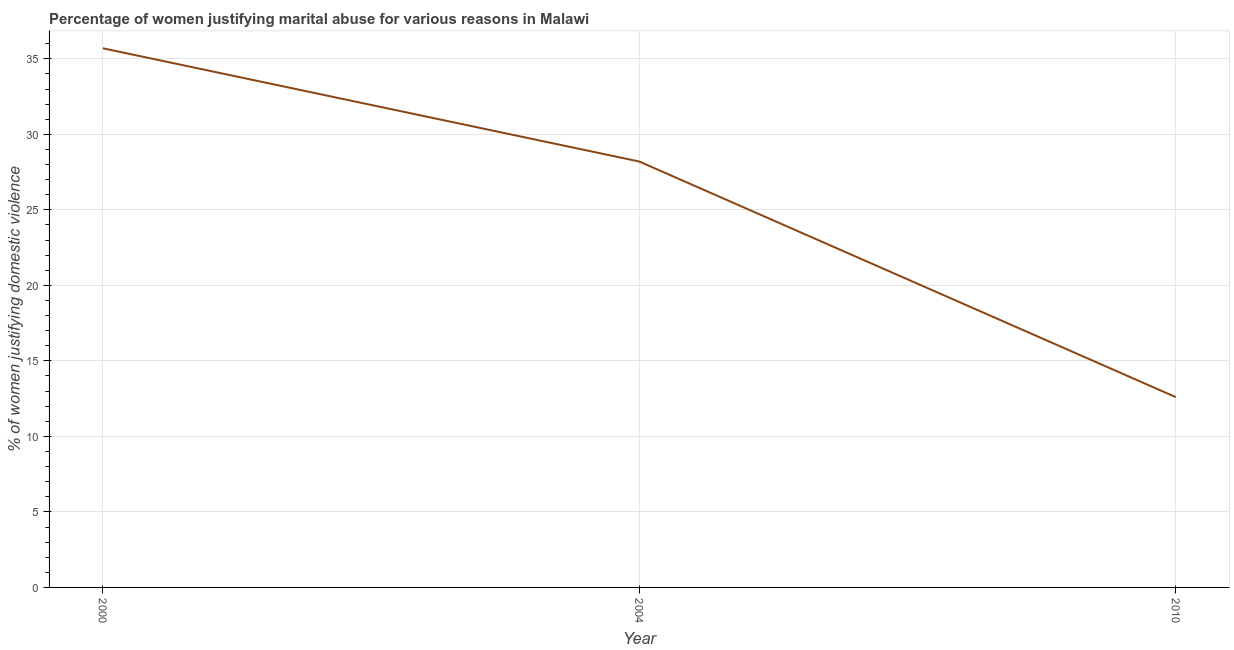What is the percentage of women justifying marital abuse in 2004?
Offer a terse response. 28.2. Across all years, what is the maximum percentage of women justifying marital abuse?
Provide a short and direct response. 35.7. Across all years, what is the minimum percentage of women justifying marital abuse?
Provide a short and direct response. 12.6. In which year was the percentage of women justifying marital abuse minimum?
Provide a short and direct response. 2010. What is the sum of the percentage of women justifying marital abuse?
Give a very brief answer. 76.5. What is the difference between the percentage of women justifying marital abuse in 2000 and 2010?
Give a very brief answer. 23.1. What is the average percentage of women justifying marital abuse per year?
Your response must be concise. 25.5. What is the median percentage of women justifying marital abuse?
Provide a short and direct response. 28.2. In how many years, is the percentage of women justifying marital abuse greater than 31 %?
Provide a short and direct response. 1. Do a majority of the years between 2010 and 2004 (inclusive) have percentage of women justifying marital abuse greater than 20 %?
Provide a short and direct response. No. What is the ratio of the percentage of women justifying marital abuse in 2000 to that in 2004?
Offer a very short reply. 1.27. Is the percentage of women justifying marital abuse in 2000 less than that in 2004?
Ensure brevity in your answer.  No. What is the difference between the highest and the second highest percentage of women justifying marital abuse?
Offer a very short reply. 7.5. What is the difference between the highest and the lowest percentage of women justifying marital abuse?
Ensure brevity in your answer.  23.1. Does the percentage of women justifying marital abuse monotonically increase over the years?
Your answer should be very brief. No. How many lines are there?
Keep it short and to the point. 1. How many years are there in the graph?
Your answer should be compact. 3. What is the difference between two consecutive major ticks on the Y-axis?
Provide a short and direct response. 5. Does the graph contain any zero values?
Offer a very short reply. No. Does the graph contain grids?
Give a very brief answer. Yes. What is the title of the graph?
Your response must be concise. Percentage of women justifying marital abuse for various reasons in Malawi. What is the label or title of the Y-axis?
Make the answer very short. % of women justifying domestic violence. What is the % of women justifying domestic violence of 2000?
Your answer should be very brief. 35.7. What is the % of women justifying domestic violence of 2004?
Keep it short and to the point. 28.2. What is the difference between the % of women justifying domestic violence in 2000 and 2004?
Ensure brevity in your answer.  7.5. What is the difference between the % of women justifying domestic violence in 2000 and 2010?
Offer a terse response. 23.1. What is the difference between the % of women justifying domestic violence in 2004 and 2010?
Offer a terse response. 15.6. What is the ratio of the % of women justifying domestic violence in 2000 to that in 2004?
Your answer should be very brief. 1.27. What is the ratio of the % of women justifying domestic violence in 2000 to that in 2010?
Offer a terse response. 2.83. What is the ratio of the % of women justifying domestic violence in 2004 to that in 2010?
Your answer should be very brief. 2.24. 